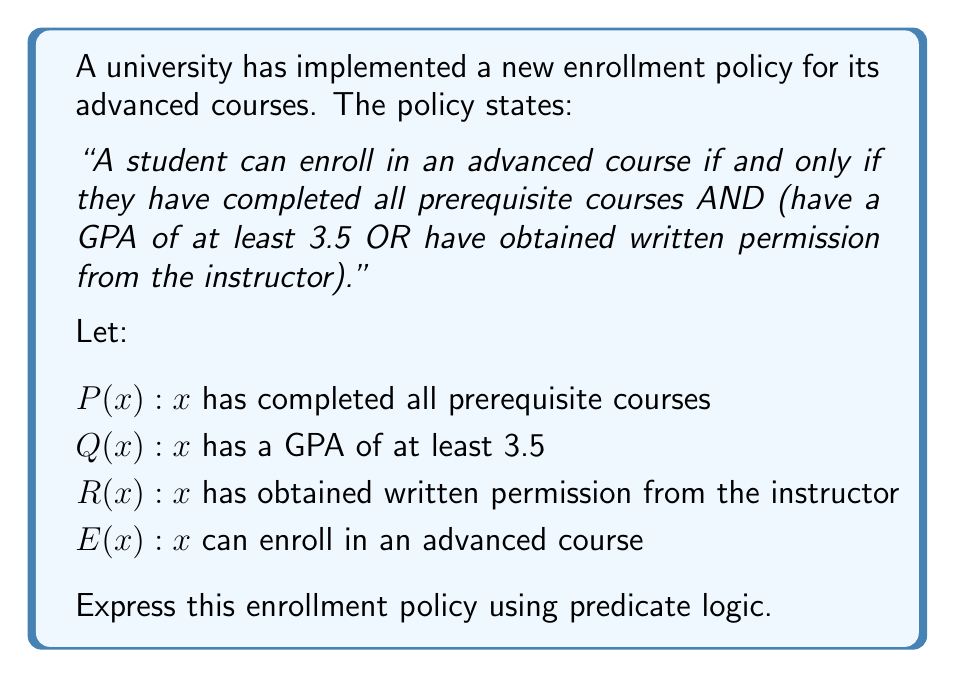Solve this math problem. To express this enrollment policy using predicate logic, we need to break down the statement and translate each part into logical symbols:

1. The policy states "if and only if", which is represented by the biconditional symbol ↔ (or ⇔).

2. The first condition "has completed all prerequisite courses" is represented by $P(x)$.

3. The second part is a combination of two conditions:
   - "have a GPA of at least 3.5" is represented by $Q(x)$
   - "have obtained written permission from the instructor" is represented by $R(x)$
   These are connected by OR, which is represented by the symbol ∨.

4. The AND connecting the first condition with the combination of the other two is represented by the symbol ∧.

5. The entire statement applies to any student x who can enroll, represented by $E(x)$.

Putting it all together, we get:

$$∀x [E(x) ↔ (P(x) ∧ (Q(x) ∨ R(x)))]$$

This reads as: "For all students x, x can enroll in an advanced course if and only if x has completed all prerequisite courses AND (x has a GPA of at least 3.5 OR x has obtained written permission from the instructor)."
Answer: $$∀x [E(x) ↔ (P(x) ∧ (Q(x) ∨ R(x)))]$$ 